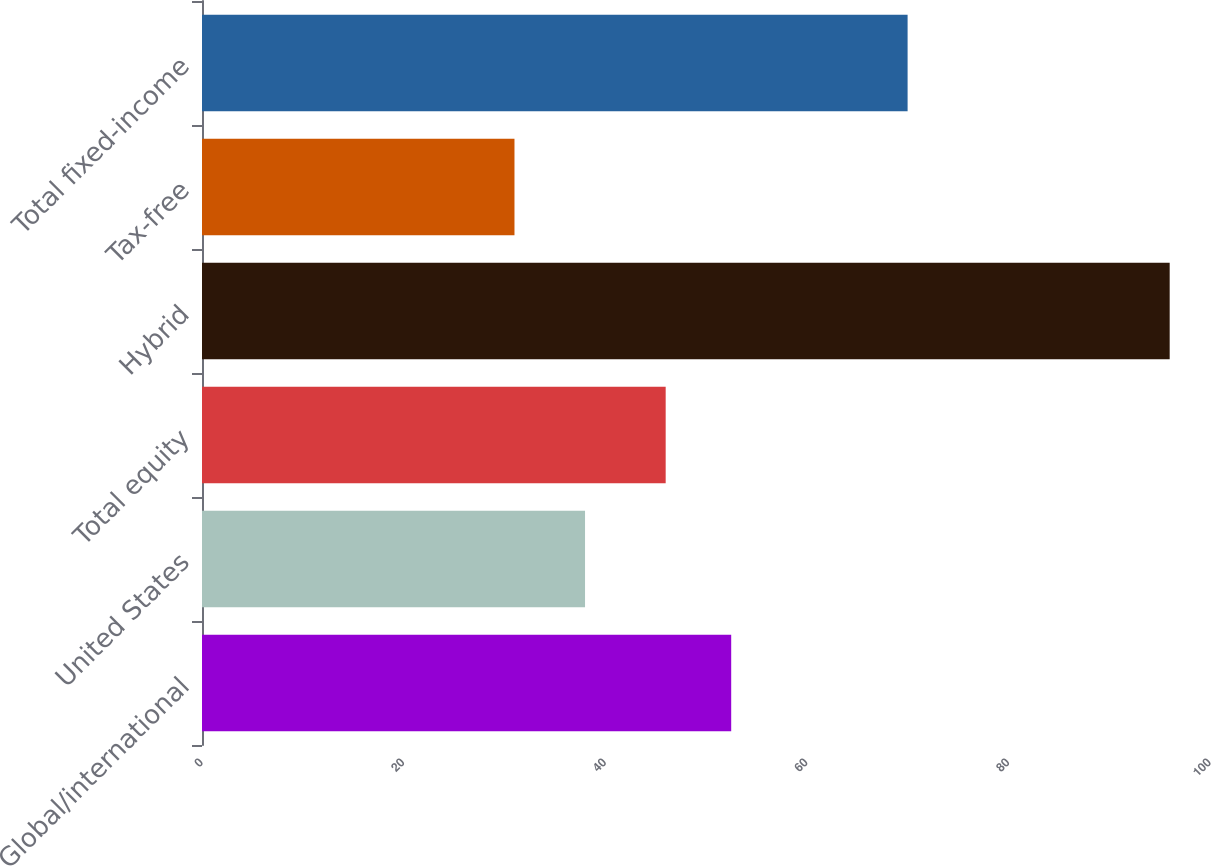Convert chart to OTSL. <chart><loc_0><loc_0><loc_500><loc_500><bar_chart><fcel>Global/international<fcel>United States<fcel>Total equity<fcel>Hybrid<fcel>Tax-free<fcel>Total fixed-income<nl><fcel>52.5<fcel>38<fcel>46<fcel>96<fcel>31<fcel>70<nl></chart> 